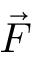Convert formula to latex. <formula><loc_0><loc_0><loc_500><loc_500>\vec { F }</formula> 